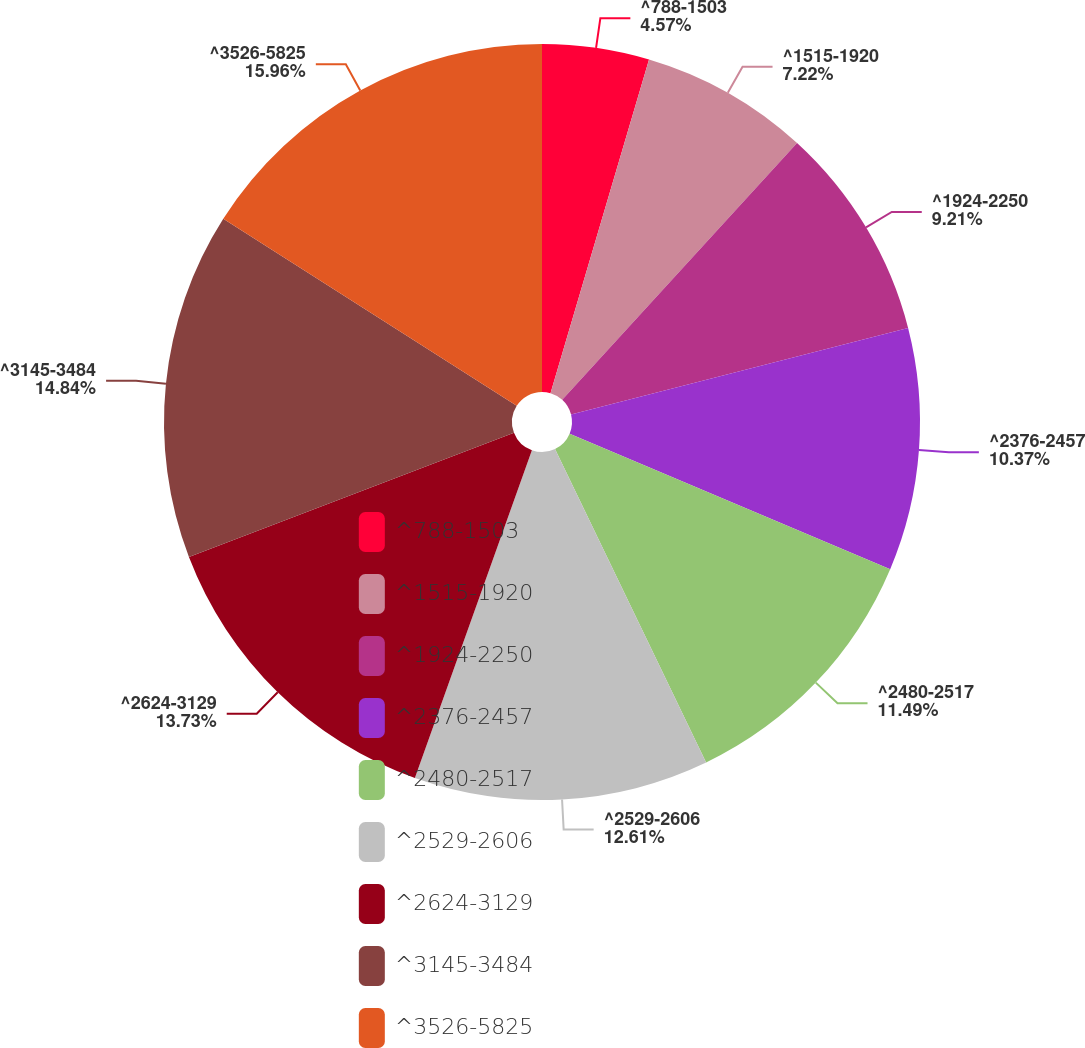<chart> <loc_0><loc_0><loc_500><loc_500><pie_chart><fcel>^788-1503<fcel>^1515-1920<fcel>^1924-2250<fcel>^2376-2457<fcel>^2480-2517<fcel>^2529-2606<fcel>^2624-3129<fcel>^3145-3484<fcel>^3526-5825<nl><fcel>4.57%<fcel>7.22%<fcel>9.21%<fcel>10.37%<fcel>11.49%<fcel>12.61%<fcel>13.73%<fcel>14.85%<fcel>15.97%<nl></chart> 